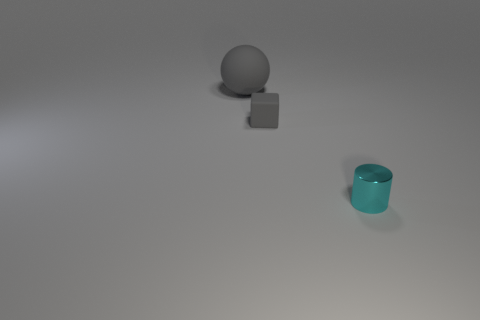Is the color of the tiny matte object the same as the big ball?
Ensure brevity in your answer.  Yes. How many things are behind the shiny object and on the right side of the gray ball?
Give a very brief answer. 1. How many tiny cubes are on the right side of the gray matte ball?
Ensure brevity in your answer.  1. How many balls are small gray things or large gray things?
Your answer should be very brief. 1. The thing that is on the left side of the small gray thing has what shape?
Offer a very short reply. Sphere. How many other gray things have the same material as the tiny gray object?
Keep it short and to the point. 1. Is the number of big gray rubber things that are on the left side of the matte ball less than the number of big purple rubber things?
Your response must be concise. No. There is a matte ball that is behind the tiny thing that is behind the small shiny object; what size is it?
Ensure brevity in your answer.  Large. There is a big thing; is it the same color as the tiny object that is behind the small shiny thing?
Provide a short and direct response. Yes. There is a gray object that is the same size as the cyan shiny cylinder; what material is it?
Your answer should be compact. Rubber. 